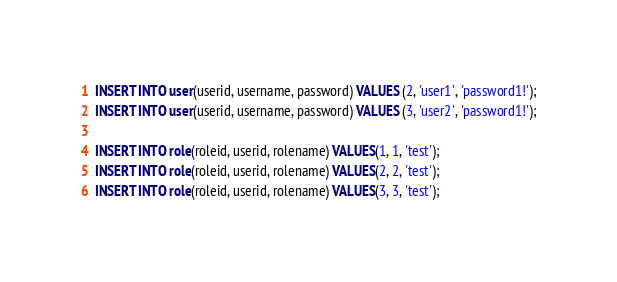<code> <loc_0><loc_0><loc_500><loc_500><_SQL_>INSERT INTO user(userid, username, password) VALUES (2, 'user1', 'password1!');
INSERT INTO user(userid, username, password) VALUES (3, 'user2', 'password1!');

INSERT INTO role(roleid, userid, rolename) VALUES(1, 1, 'test');
INSERT INTO role(roleid, userid, rolename) VALUES(2, 2, 'test');
INSERT INTO role(roleid, userid, rolename) VALUES(3, 3, 'test');

</code> 